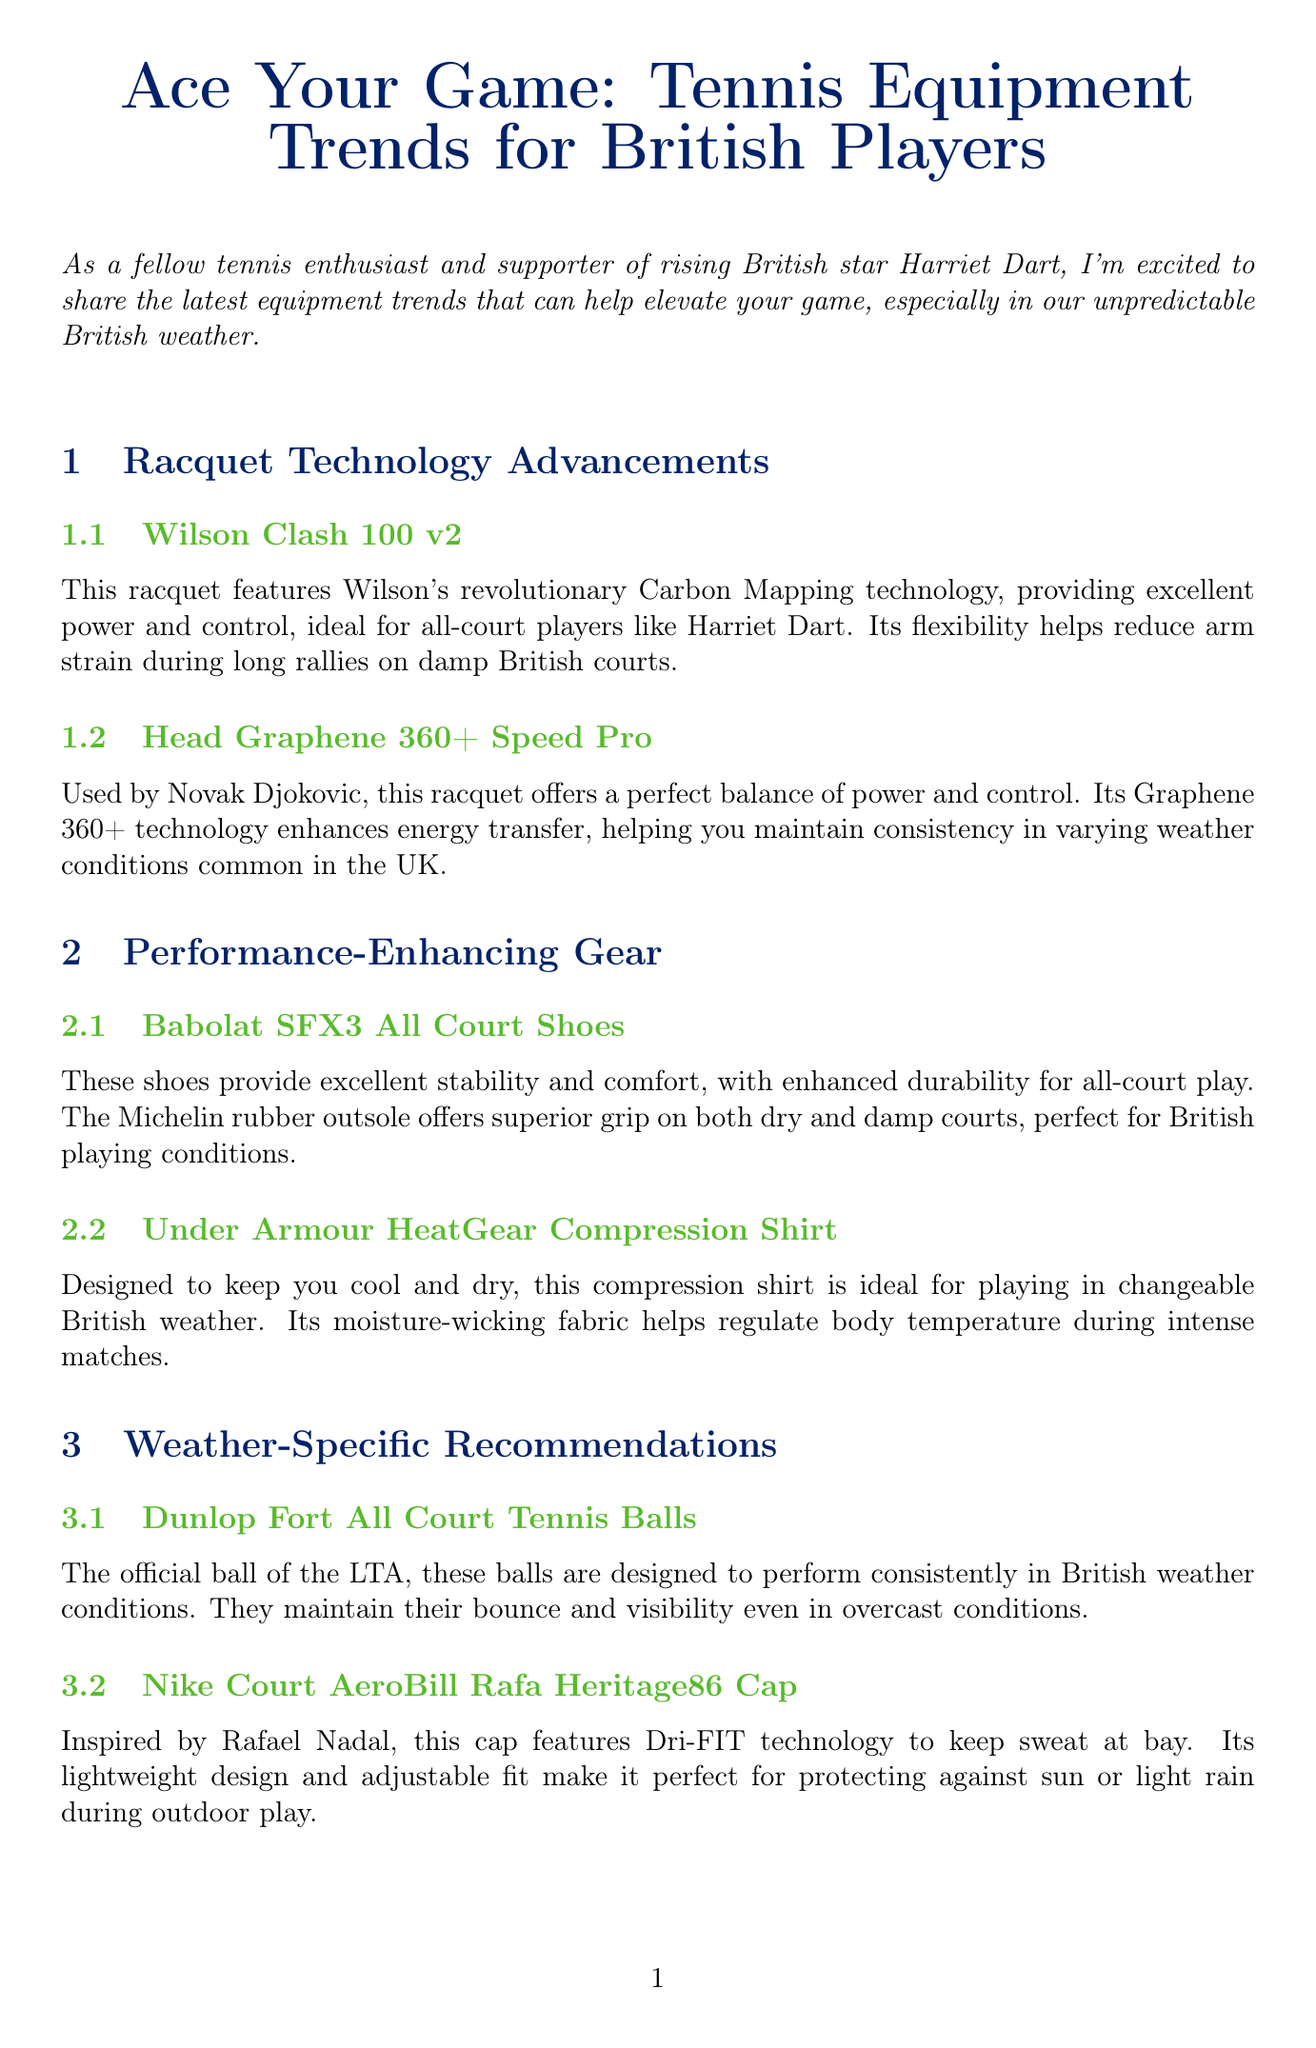What is the title of the newsletter? The title of the newsletter is stated at the beginning of the document, which is "Ace Your Game: Tennis Equipment Trends for British Players."
Answer: Ace Your Game: Tennis Equipment Trends for British Players Who uses the Head Graphene 360+ Speed Pro racquet? The document mentions that this racquet is used by Novak Djokovic.
Answer: Novak Djokovic What technology does the Wilson Clash 100 v2 racquet feature? The document specifies that this racquet features Wilson's Carbon Mapping technology.
Answer: Carbon Mapping technology What is a recommended shoe for playing in British conditions? The document lists the Babolat SFX3 All Court Shoes as a performance-enhancing gear ideal for British conditions.
Answer: Babolat SFX3 All Court Shoes Which player is highlighted in the newsletter? The spotlight section of the newsletter specifically mentions Harriet Dart.
Answer: Harriet Dart What type of balls are recommended for British weather conditions? According to the document, the Dunlop Fort All Court Tennis Balls are designed to perform consistently in British weather.
Answer: Dunlop Fort All Court Tennis Balls What is the location of the featured local pro shop? The document indicates that the featured pro shop, Tennis Vision, is located in London.
Answer: London What design feature does the Nike Court AeroBill Rafa Heritage86 Cap have? The document describes the cap as featuring Dri-FIT technology.
Answer: Dri-FIT technology 